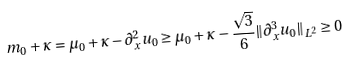Convert formula to latex. <formula><loc_0><loc_0><loc_500><loc_500>m _ { 0 } + \kappa = \mu _ { 0 } + \kappa - \partial _ { x } ^ { 2 } u _ { 0 } \geq \mu _ { 0 } + \kappa - \frac { \sqrt { 3 } } { 6 } \| \partial _ { x } ^ { 3 } u _ { 0 } \| _ { L ^ { 2 } } \geq 0</formula> 